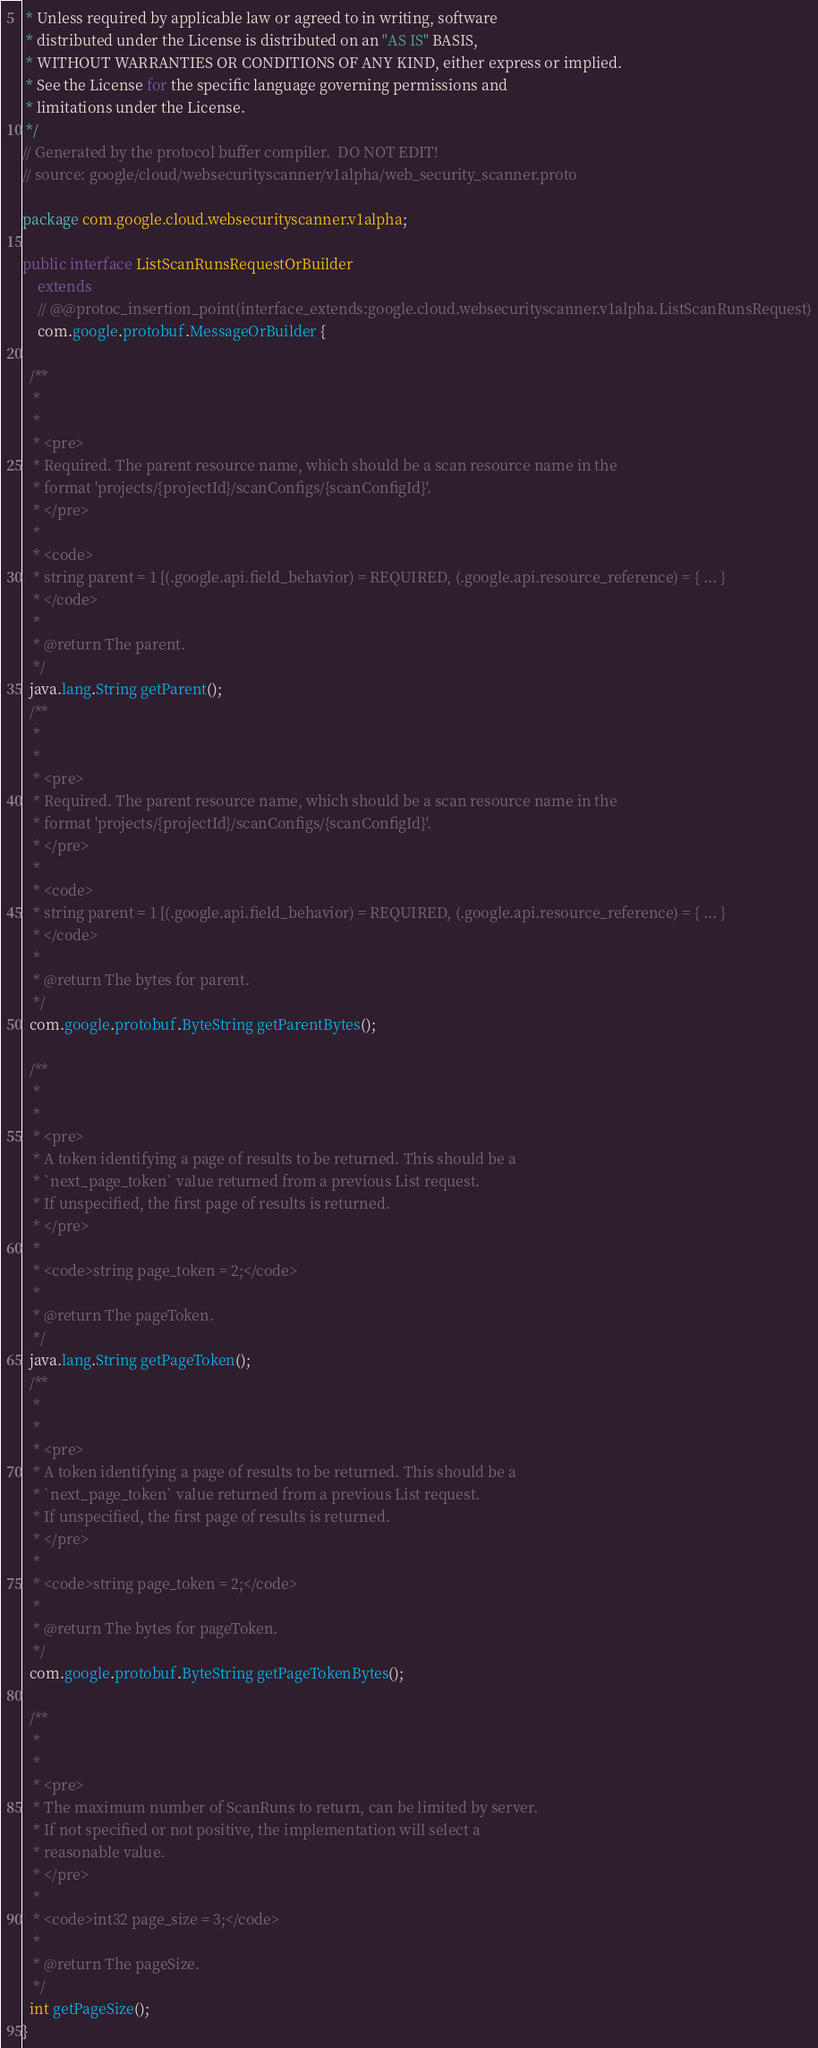<code> <loc_0><loc_0><loc_500><loc_500><_Java_> * Unless required by applicable law or agreed to in writing, software
 * distributed under the License is distributed on an "AS IS" BASIS,
 * WITHOUT WARRANTIES OR CONDITIONS OF ANY KIND, either express or implied.
 * See the License for the specific language governing permissions and
 * limitations under the License.
 */
// Generated by the protocol buffer compiler.  DO NOT EDIT!
// source: google/cloud/websecurityscanner/v1alpha/web_security_scanner.proto

package com.google.cloud.websecurityscanner.v1alpha;

public interface ListScanRunsRequestOrBuilder
    extends
    // @@protoc_insertion_point(interface_extends:google.cloud.websecurityscanner.v1alpha.ListScanRunsRequest)
    com.google.protobuf.MessageOrBuilder {

  /**
   *
   *
   * <pre>
   * Required. The parent resource name, which should be a scan resource name in the
   * format 'projects/{projectId}/scanConfigs/{scanConfigId}'.
   * </pre>
   *
   * <code>
   * string parent = 1 [(.google.api.field_behavior) = REQUIRED, (.google.api.resource_reference) = { ... }
   * </code>
   *
   * @return The parent.
   */
  java.lang.String getParent();
  /**
   *
   *
   * <pre>
   * Required. The parent resource name, which should be a scan resource name in the
   * format 'projects/{projectId}/scanConfigs/{scanConfigId}'.
   * </pre>
   *
   * <code>
   * string parent = 1 [(.google.api.field_behavior) = REQUIRED, (.google.api.resource_reference) = { ... }
   * </code>
   *
   * @return The bytes for parent.
   */
  com.google.protobuf.ByteString getParentBytes();

  /**
   *
   *
   * <pre>
   * A token identifying a page of results to be returned. This should be a
   * `next_page_token` value returned from a previous List request.
   * If unspecified, the first page of results is returned.
   * </pre>
   *
   * <code>string page_token = 2;</code>
   *
   * @return The pageToken.
   */
  java.lang.String getPageToken();
  /**
   *
   *
   * <pre>
   * A token identifying a page of results to be returned. This should be a
   * `next_page_token` value returned from a previous List request.
   * If unspecified, the first page of results is returned.
   * </pre>
   *
   * <code>string page_token = 2;</code>
   *
   * @return The bytes for pageToken.
   */
  com.google.protobuf.ByteString getPageTokenBytes();

  /**
   *
   *
   * <pre>
   * The maximum number of ScanRuns to return, can be limited by server.
   * If not specified or not positive, the implementation will select a
   * reasonable value.
   * </pre>
   *
   * <code>int32 page_size = 3;</code>
   *
   * @return The pageSize.
   */
  int getPageSize();
}
</code> 